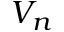Convert formula to latex. <formula><loc_0><loc_0><loc_500><loc_500>V _ { n }</formula> 